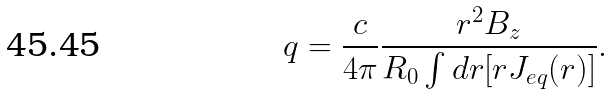<formula> <loc_0><loc_0><loc_500><loc_500>q = \frac { c } { 4 \pi } \frac { r ^ { 2 } B _ { z } } { R _ { 0 } \int d r [ r J _ { e q } ( r ) ] } .</formula> 